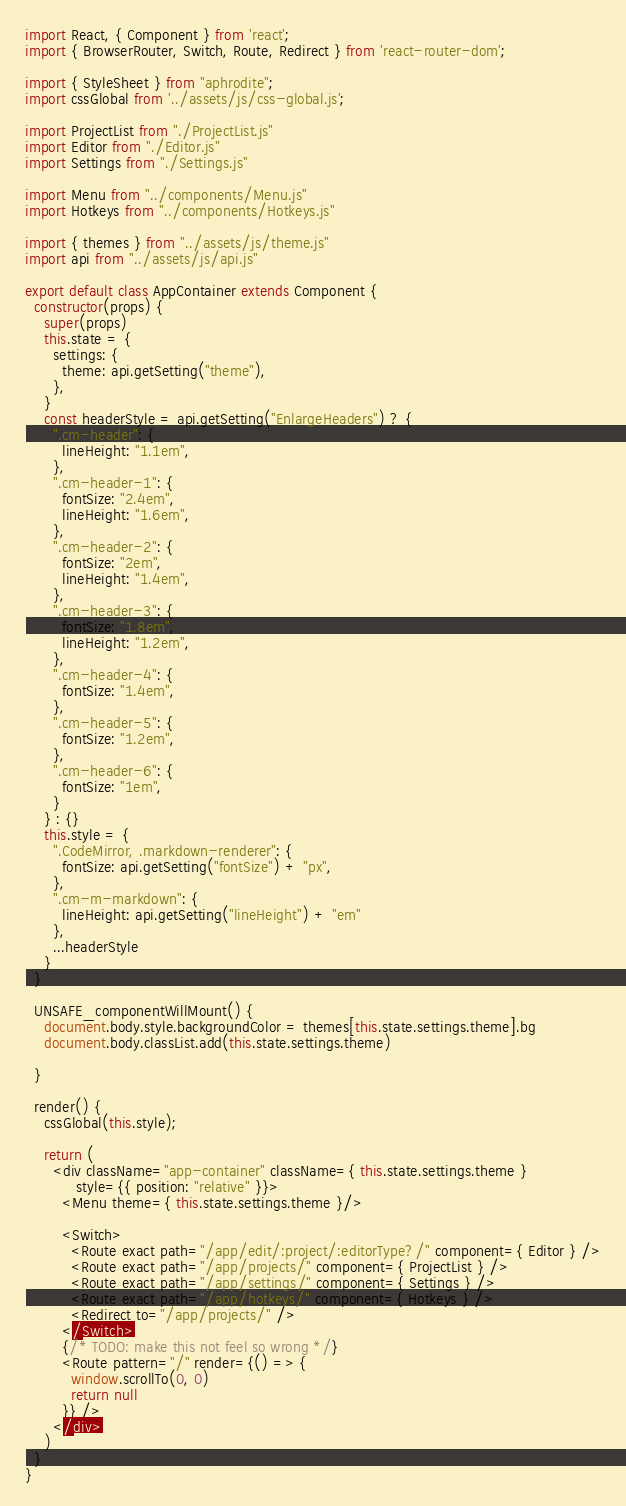<code> <loc_0><loc_0><loc_500><loc_500><_JavaScript_>import React, { Component } from 'react';
import { BrowserRouter, Switch, Route, Redirect } from 'react-router-dom';

import { StyleSheet } from "aphrodite";
import cssGlobal from '../assets/js/css-global.js';

import ProjectList from "./ProjectList.js"
import Editor from "./Editor.js"
import Settings from "./Settings.js"

import Menu from "../components/Menu.js"
import Hotkeys from "../components/Hotkeys.js"

import { themes } from "../assets/js/theme.js"
import api from "../assets/js/api.js"

export default class AppContainer extends Component {
  constructor(props) {
    super(props)
    this.state = {
      settings: {
        theme: api.getSetting("theme"),
      },
    }
    const headerStyle = api.getSetting("EnlargeHeaders") ? {
      ".cm-header": {
        lineHeight: "1.1em",
      },
      ".cm-header-1": {
        fontSize: "2.4em",
        lineHeight: "1.6em",
      },
      ".cm-header-2": {
        fontSize: "2em",
        lineHeight: "1.4em",
      },
      ".cm-header-3": {
        fontSize: "1.8em",
        lineHeight: "1.2em",
      },
      ".cm-header-4": {
        fontSize: "1.4em",
      },
      ".cm-header-5": {
        fontSize: "1.2em",
      },
      ".cm-header-6": {
        fontSize: "1em",
      }
    } : {}
    this.style = {
      ".CodeMirror, .markdown-renderer": {
        fontSize: api.getSetting("fontSize") + "px",
      },
      ".cm-m-markdown": {
        lineHeight: api.getSetting("lineHeight") + "em"
      },
      ...headerStyle
    }
  }

  UNSAFE_componentWillMount() {
    document.body.style.backgroundColor = themes[this.state.settings.theme].bg
    document.body.classList.add(this.state.settings.theme)

  }

  render() {
    cssGlobal(this.style);

    return (
      <div className="app-container" className={ this.state.settings.theme }
           style={{ position: "relative" }}>
        <Menu theme={ this.state.settings.theme }/>

        <Switch>
          <Route exact path="/app/edit/:project/:editorType?/" component={ Editor } />
          <Route exact path="/app/projects/" component={ ProjectList } />
          <Route exact path="/app/settings/" component={ Settings } />
          <Route exact path="/app/hotkeys/" component={ Hotkeys } />
          <Redirect to="/app/projects/" />
        </Switch>
        {/* TODO: make this not feel so wrong */}
        <Route pattern="/" render={() => {
          window.scrollTo(0, 0)
          return null
        }} />
      </div>
    )
  }
}
</code> 